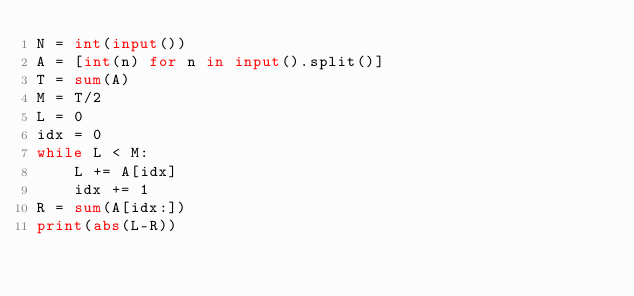<code> <loc_0><loc_0><loc_500><loc_500><_Python_>N = int(input())
A = [int(n) for n in input().split()]
T = sum(A)
M = T/2
L = 0
idx = 0
while L < M:
    L += A[idx]
    idx += 1
R = sum(A[idx:])
print(abs(L-R))</code> 